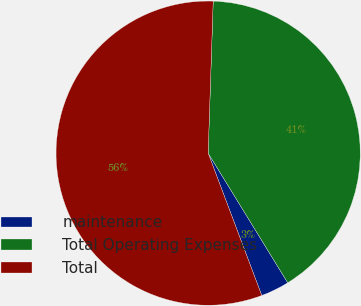Convert chart to OTSL. <chart><loc_0><loc_0><loc_500><loc_500><pie_chart><fcel>maintenance<fcel>Total Operating Expenses<fcel>Total<nl><fcel>3.03%<fcel>40.71%<fcel>56.26%<nl></chart> 